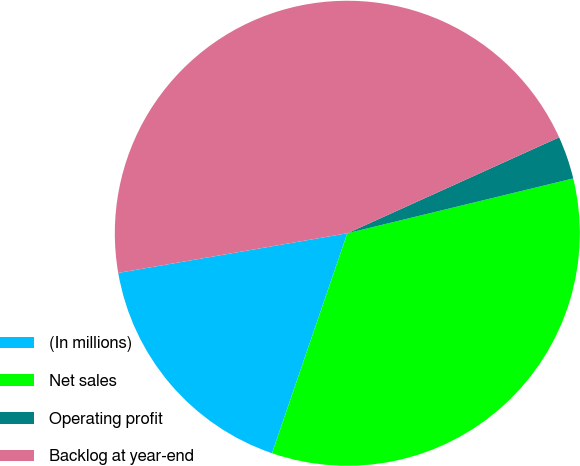Convert chart. <chart><loc_0><loc_0><loc_500><loc_500><pie_chart><fcel>(In millions)<fcel>Net sales<fcel>Operating profit<fcel>Backlog at year-end<nl><fcel>17.02%<fcel>34.04%<fcel>2.98%<fcel>45.96%<nl></chart> 